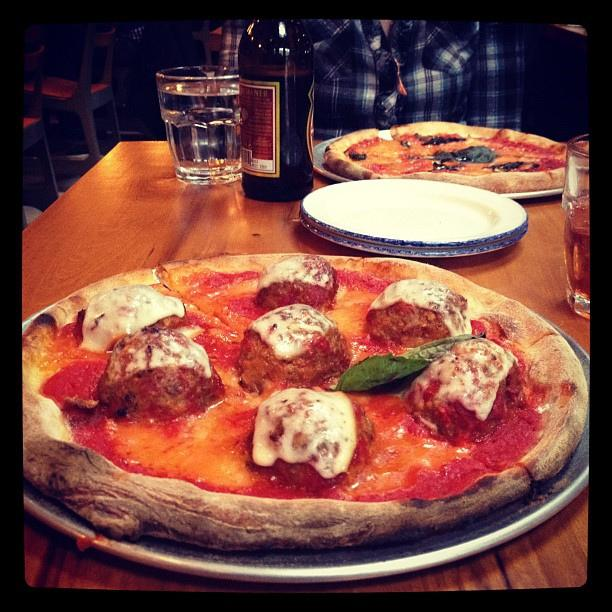The two pizzas have different sized what? Please explain your reasoning. toppings. There are meatballs on one and not the other. 